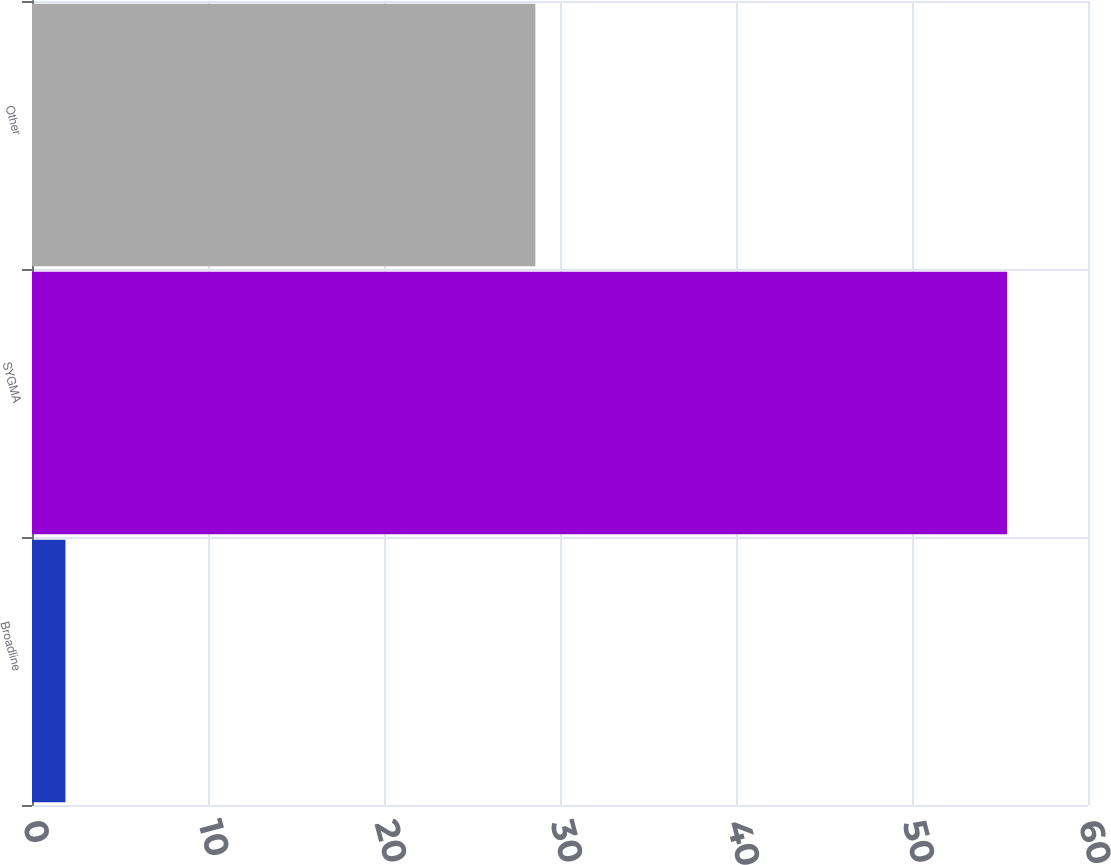Convert chart to OTSL. <chart><loc_0><loc_0><loc_500><loc_500><bar_chart><fcel>Broadline<fcel>SYGMA<fcel>Other<nl><fcel>1.9<fcel>55.4<fcel>28.6<nl></chart> 